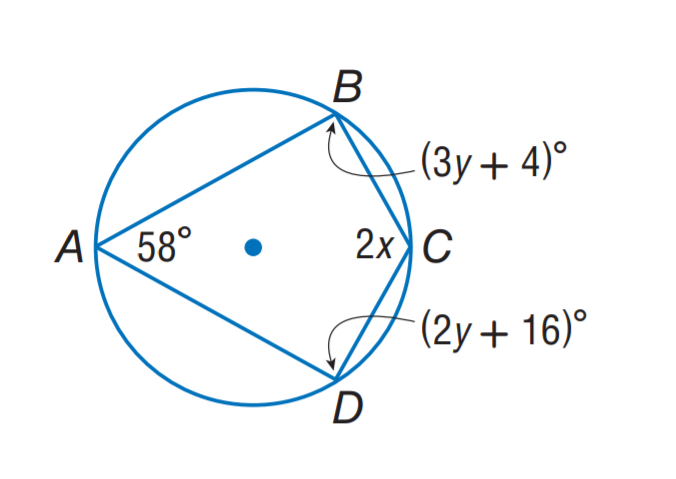Answer the mathemtical geometry problem and directly provide the correct option letter.
Question: Find m \angle C.
Choices: A: 80 B: 100 C: 112 D: 122 D 